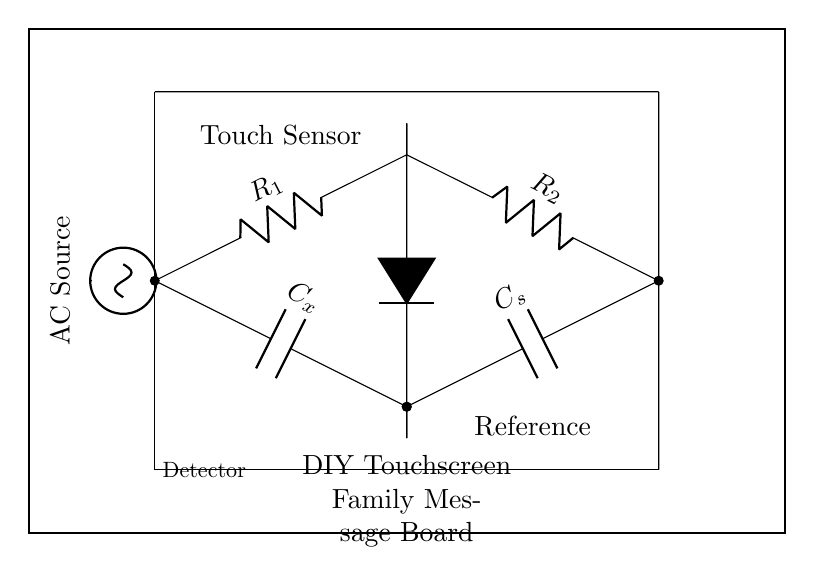What is the function of the component labeled C_x? C_x is a capacitor in the bridge circuit that helps measure capacitance changes when a touch is detected on the sensor.
Answer: Capacitor What does the detector in the circuit do? The detector measures the difference in potential between two branches of the bridge circuit, indicating touch.
Answer: Measure difference What is the significance of the AC source in this circuit? The AC source provides an alternating current that is necessary for the capacitive touch sensing to work effectively.
Answer: Provide power How many resistors are used in this circuit? There are two resistors shown in the circuit, labeled as R_1 and R_2.
Answer: Two Why are there two capacitors in the bridge circuit? The two capacitors (C_x and C_s) are used to create a balance in the bridge; one is the unknown capacitance while the other acts as a reference.
Answer: Create balance What component directly indicates a touch on the sensor? The component that indicates a touch is the detector, which responds to capacitance changes.
Answer: Detector What is the overall purpose of the circuit depicted? The overall purpose is to create a touchscreen interface for a family message board using capacitive sensing.
Answer: Touchscreen interface 